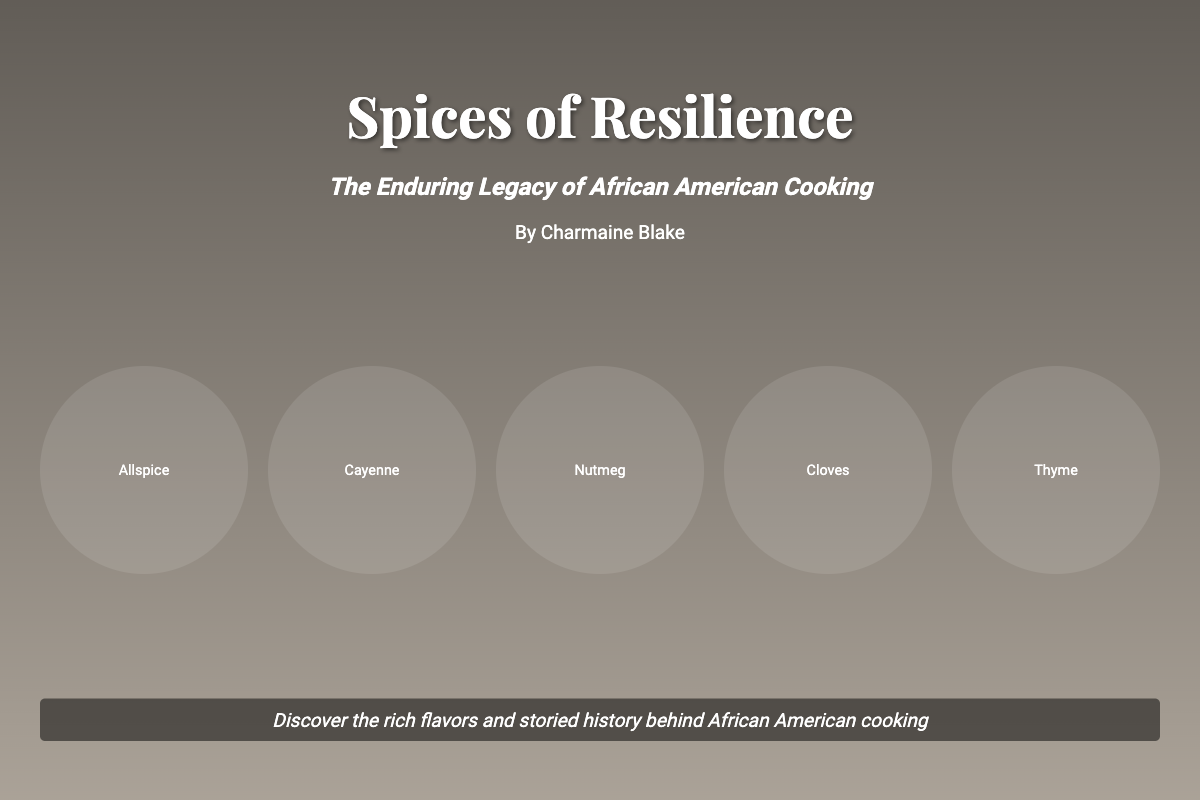What is the title of the book? The title of the book is prominently displayed at the top of the cover.
Answer: Spices of Resilience Who is the author of the book? The author's name is provided below the subtitle on the cover.
Answer: Charmaine Blake What is the subtitle of the book? The subtitle is located right below the title and provides context about the book's focus.
Answer: The Enduring Legacy of African American Cooking How many spices are listed on the cover? The number of spice items is indicated by the grid displaying spice names.
Answer: 5 What color scheme is used for the book cover? The cover features a vibrant color scheme inspired by spice markets and bold textures.
Answer: Bold colors What does the tagline on the cover encourage readers to do? The tagline summarizes the theme of exploration and discovery related to the culinary history presented in the book.
Answer: Discover the rich flavors and storied history What type of design elements are featured on the book cover? The elements include images of spices and herbs, as well as African American cooks depicted in culinary moments.
Answer: Spice images and cooks What aspect of African American history does this book focus on? The focus is on the contributions of African Americans to the culinary field.
Answer: Culinary contributions What is the background image of the book cover? The background image represents a vibrant spice market, enhancing the theme of the book.
Answer: Spice market 